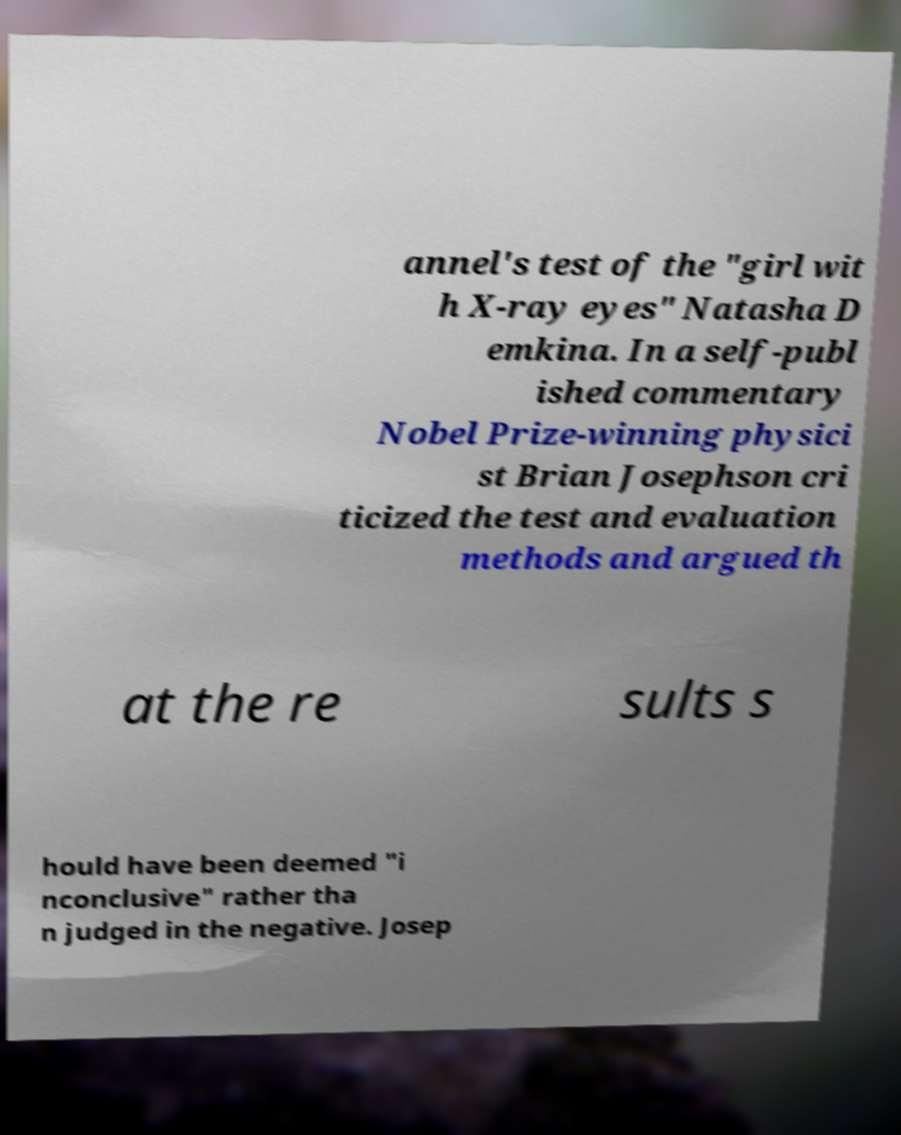What messages or text are displayed in this image? I need them in a readable, typed format. annel's test of the "girl wit h X-ray eyes" Natasha D emkina. In a self-publ ished commentary Nobel Prize-winning physici st Brian Josephson cri ticized the test and evaluation methods and argued th at the re sults s hould have been deemed "i nconclusive" rather tha n judged in the negative. Josep 